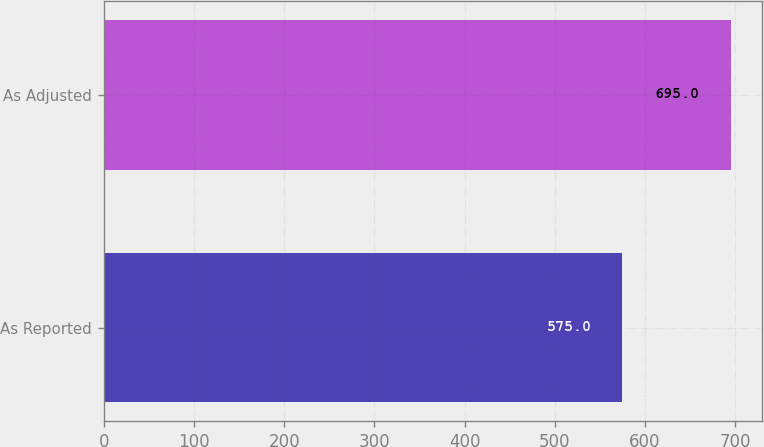Convert chart to OTSL. <chart><loc_0><loc_0><loc_500><loc_500><bar_chart><fcel>As Reported<fcel>As Adjusted<nl><fcel>575<fcel>695<nl></chart> 